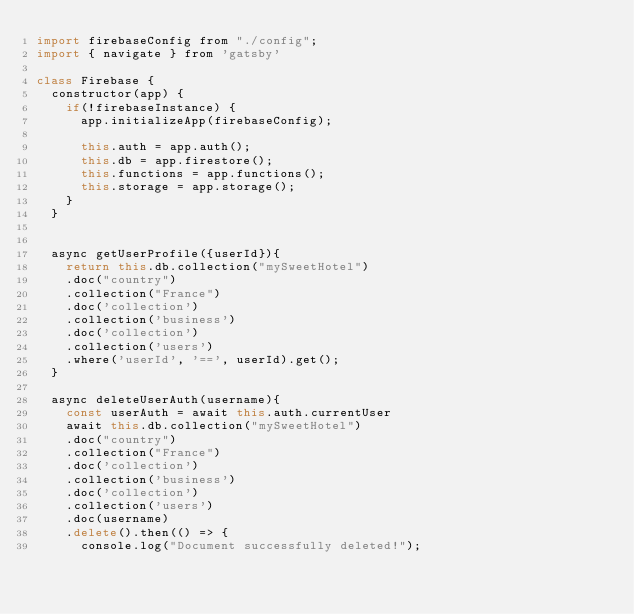<code> <loc_0><loc_0><loc_500><loc_500><_JavaScript_>import firebaseConfig from "./config";
import { navigate } from 'gatsby'

class Firebase {
  constructor(app) {
    if(!firebaseInstance) {
      app.initializeApp(firebaseConfig);

      this.auth = app.auth();
      this.db = app.firestore();
      this.functions = app.functions();
      this.storage = app.storage();
    }
  }


  async getUserProfile({userId}){
    return this.db.collection("mySweetHotel")
    .doc("country")
    .collection("France")
    .doc('collection')
    .collection('business')
    .doc('collection')
    .collection('users')
    .where('userId', '==', userId).get();
  }

  async deleteUserAuth(username){
    const userAuth = await this.auth.currentUser
    await this.db.collection("mySweetHotel")
    .doc("country")
    .collection("France")
    .doc('collection')
    .collection('business')
    .doc('collection')
    .collection('users')
    .doc(username)
    .delete().then(() => {
      console.log("Document successfully deleted!");</code> 